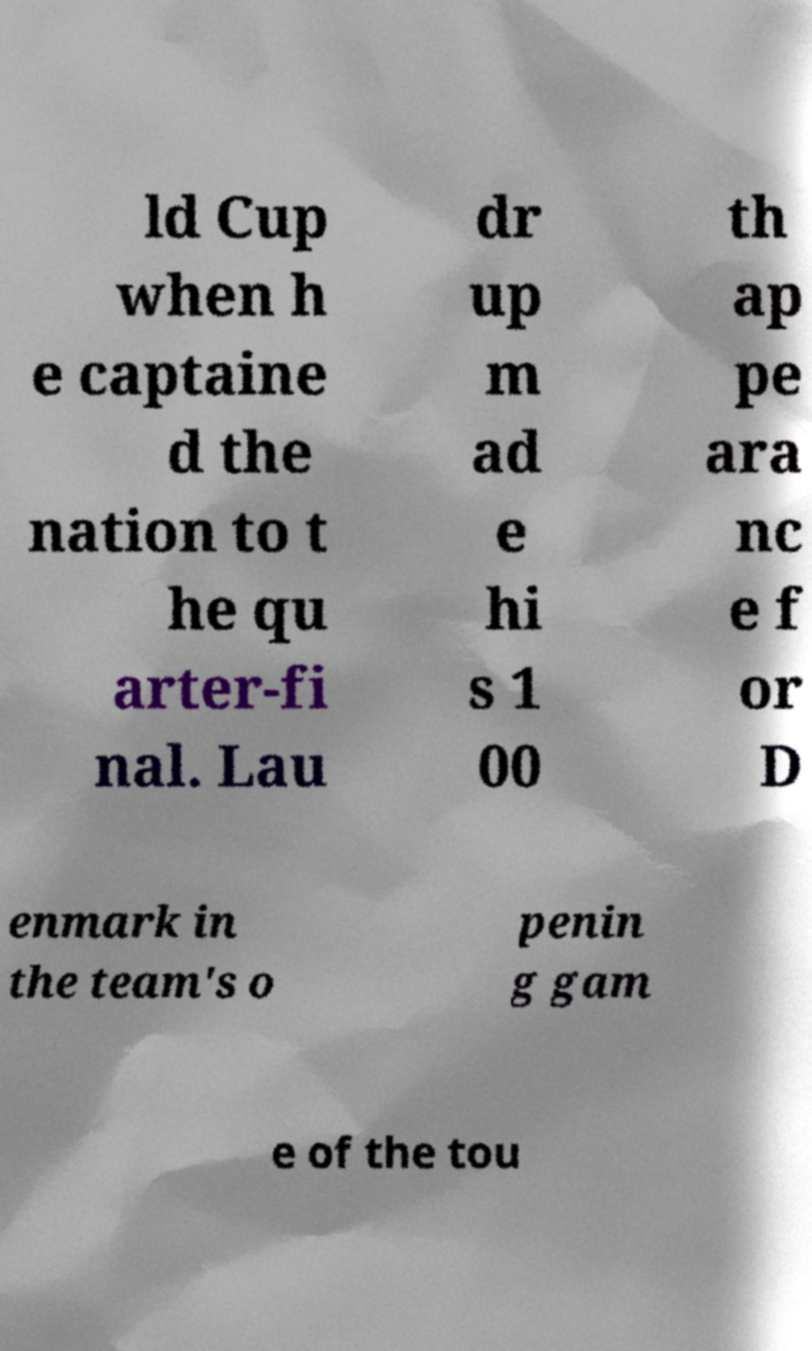Please read and relay the text visible in this image. What does it say? ld Cup when h e captaine d the nation to t he qu arter-fi nal. Lau dr up m ad e hi s 1 00 th ap pe ara nc e f or D enmark in the team's o penin g gam e of the tou 